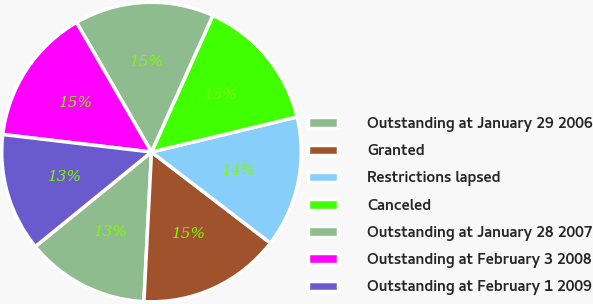<chart> <loc_0><loc_0><loc_500><loc_500><pie_chart><fcel>Outstanding at January 29 2006<fcel>Granted<fcel>Restrictions lapsed<fcel>Canceled<fcel>Outstanding at January 28 2007<fcel>Outstanding at February 3 2008<fcel>Outstanding at February 1 2009<nl><fcel>13.32%<fcel>15.41%<fcel>14.16%<fcel>14.52%<fcel>15.06%<fcel>14.79%<fcel>12.74%<nl></chart> 